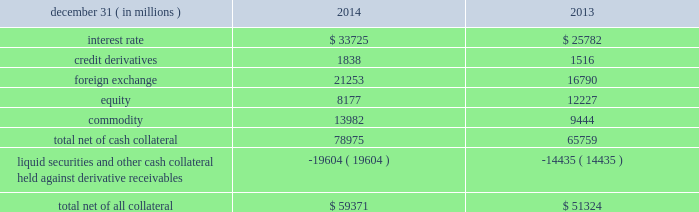Jpmorgan chase & co./2014 annual report 125 lending-related commitments the firm uses lending-related financial instruments , such as commitments ( including revolving credit facilities ) and guarantees , to meet the financing needs of its customers .
The contractual amounts of these financial instruments represent the maximum possible credit risk should the counterparties draw down on these commitments or the firm fulfills its obligations under these guarantees , and the counterparties subsequently fail to perform according to the terms of these contracts .
In the firm 2019s view , the total contractual amount of these wholesale lending-related commitments is not representative of the firm 2019s actual future credit exposure or funding requirements .
In determining the amount of credit risk exposure the firm has to wholesale lending-related commitments , which is used as the basis for allocating credit risk capital to these commitments , the firm has established a 201cloan-equivalent 201d amount for each commitment ; this amount represents the portion of the unused commitment or other contingent exposure that is expected , based on average portfolio historical experience , to become drawn upon in an event of a default by an obligor .
The loan-equivalent amount of the firm 2019s lending- related commitments was $ 229.6 billion and $ 218.9 billion as of december 31 , 2014 and 2013 , respectively .
Clearing services the firm provides clearing services for clients entering into securities and derivative transactions .
Through the provision of these services the firm is exposed to the risk of non-performance by its clients and may be required to share in losses incurred by central counterparties ( 201cccps 201d ) .
Where possible , the firm seeks to mitigate its credit risk to its clients through the collection of adequate margin at inception and throughout the life of the transactions and can also cease provision of clearing services if clients do not adhere to their obligations under the clearing agreement .
For further discussion of clearing services , see note 29 .
Derivative contracts in the normal course of business , the firm uses derivative instruments predominantly for market-making activities .
Derivatives enable customers to manage exposures to fluctuations in interest rates , currencies and other markets .
The firm also uses derivative instruments to manage its own credit exposure .
The nature of the counterparty and the settlement mechanism of the derivative affect the credit risk to which the firm is exposed .
For otc derivatives the firm is exposed to the credit risk of the derivative counterparty .
For exchange-traded derivatives ( 201cetd 201d ) such as futures and options , and 201ccleared 201d over-the-counter ( 201cotc-cleared 201d ) derivatives , the firm is generally exposed to the credit risk of the relevant ccp .
Where possible , the firm seeks to mitigate its credit risk exposures arising from derivative transactions through the use of legally enforceable master netting arrangements and collateral agreements .
For further discussion of derivative contracts , counterparties and settlement types , see note 6 .
The table summarizes the net derivative receivables for the periods presented .
Derivative receivables .
Derivative receivables reported on the consolidated balance sheets were $ 79.0 billion and $ 65.8 billion at december 31 , 2014 and 2013 , respectively .
These amounts represent the fair value of the derivative contracts , after giving effect to legally enforceable master netting agreements and cash collateral held by the firm .
However , in management 2019s view , the appropriate measure of current credit risk should also take into consideration additional liquid securities ( primarily u.s .
Government and agency securities and other g7 government bonds ) and other cash collateral held by the firm aggregating $ 19.6 billion and $ 14.4 billion at december 31 , 2014 and 2013 , respectively , that may be used as security when the fair value of the client 2019s exposure is in the firm 2019s favor .
In addition to the collateral described in the preceding paragraph , the firm also holds additional collateral ( primarily : cash ; g7 government securities ; other liquid government-agency and guaranteed securities ; and corporate debt and equity securities ) delivered by clients at the initiation of transactions , as well as collateral related to contracts that have a non-daily call frequency and collateral that the firm has agreed to return but has not yet settled as of the reporting date .
Although this collateral does not reduce the balances and is not included in the table above , it is available as security against potential exposure that could arise should the fair value of the client 2019s derivative transactions move in the firm 2019s favor .
As of december 31 , 2014 and 2013 , the firm held $ 48.6 billion and $ 50.8 billion , respectively , of this additional collateral .
The prior period amount has been revised to conform with the current period presentation .
The derivative receivables fair value , net of all collateral , also does not include other credit enhancements , such as letters of credit .
For additional information on the firm 2019s use of collateral agreements , see note 6. .
What was the annual average number of liquid securities and other cash considerations? 
Rationale: add the total number of liquid securities from 2013 and 2014 , to get 34039 million , and then divide by the total number of years , 2 .
Computations: ((19604 + 14435) / 2)
Answer: 17019.5. 